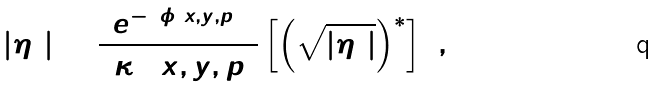<formula> <loc_0><loc_0><loc_500><loc_500>| \eta _ { 4 } | = \frac { e ^ { - 2 \phi ( x , y , p ) } } { 2 \kappa ^ { 2 } ( x , y , p ) } \left [ \left ( \sqrt { | \eta _ { 5 } | } \right ) ^ { \ast } \right ] ^ { 2 } ,</formula> 